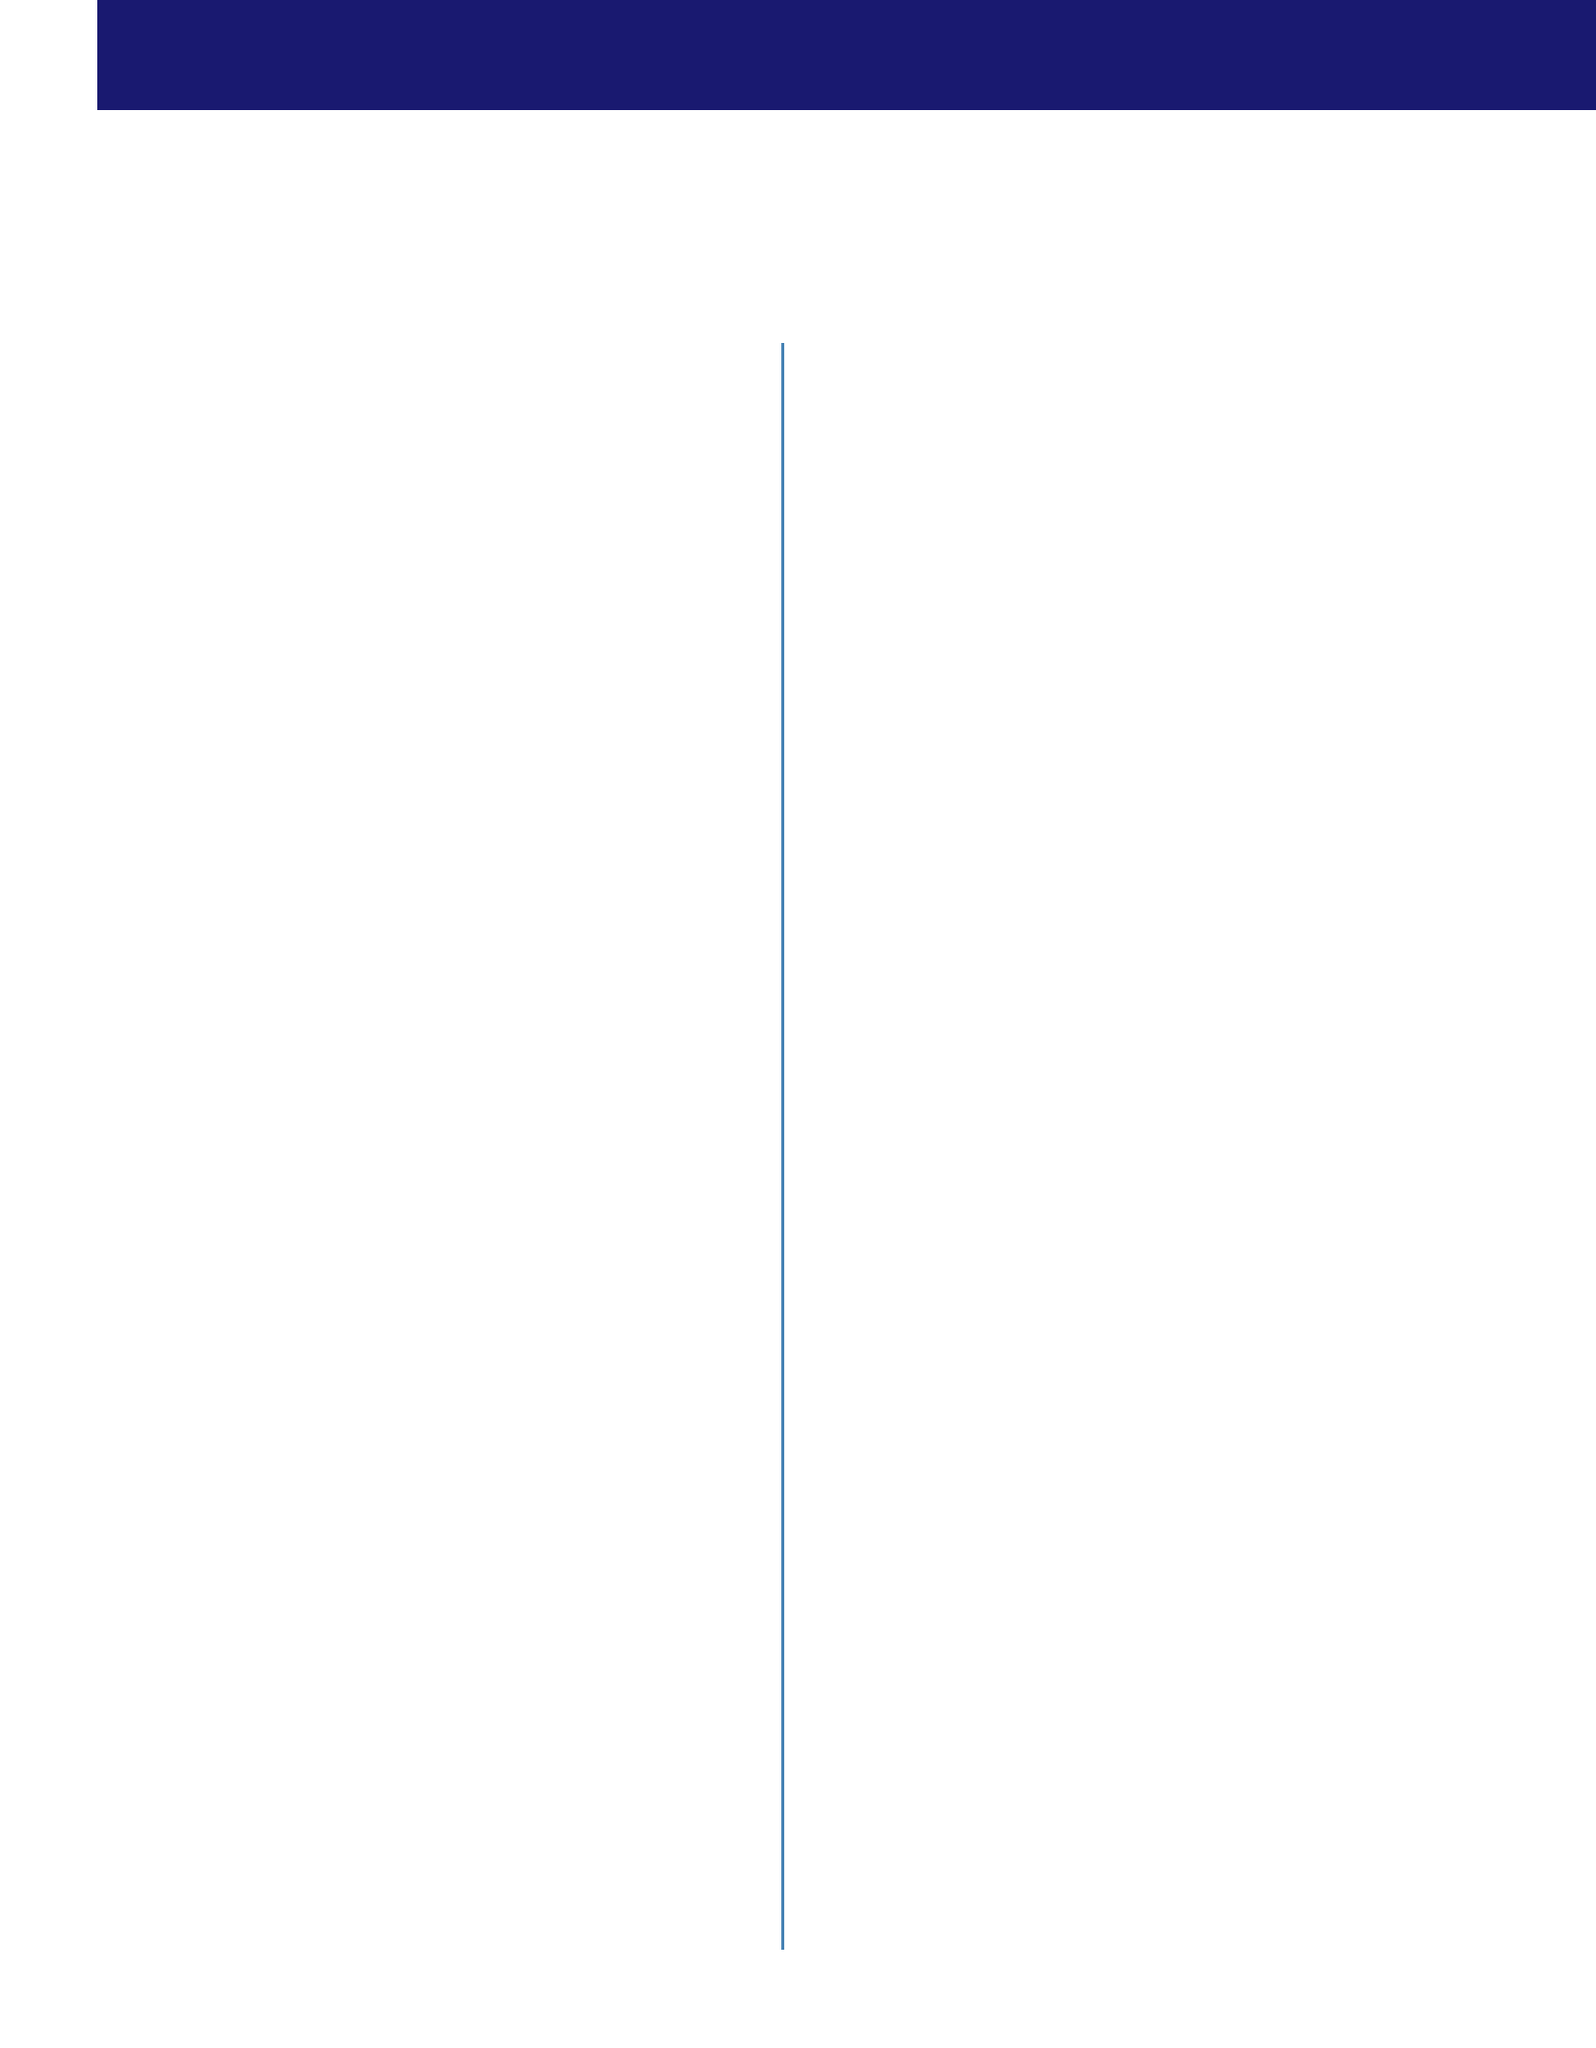What is the name of the event? The event name is mentioned in the document under "event_details."
Answer: Midwest Manufacturing Workforce Reboot Where is the event located? The location of the event can be found in the "event_details" section.
Answer: Gary/Chicago International Airport Convention Center How many days does the event last? The duration of the event is specified in the "event_details" section.
Answer: 2 days Who is the keynote speaker from the U.S. Secretary of Transportation? This information is available in the "keynote_speakers" section of the document.
Answer: Pete Buttigieg What is one of the key objectives of the event? The objectives are listed under "key_objectives" and can be extracted.
Answer: Connect displaced workers with new job opportunities Which committee is involved in planning the event? The planning committee members are listed in the "planning_committee" section.
Answer: United Auto Workers Local 551 What type of resources will be showcased at the Local Economic Development section? The resources are outlined in the "local_economic_development_showcase" section of the document.
Answer: Northwest Indiana Forum What service is provided by the Indiana Career Connect? This information can be found in the "support_services" section.
Answer: Career Counseling What are participants evaluated on at the Skills Assessment Center? This can be deduced from the description in the "main_event_sections" for the Skills Assessment Center.
Answer: Their current skills 